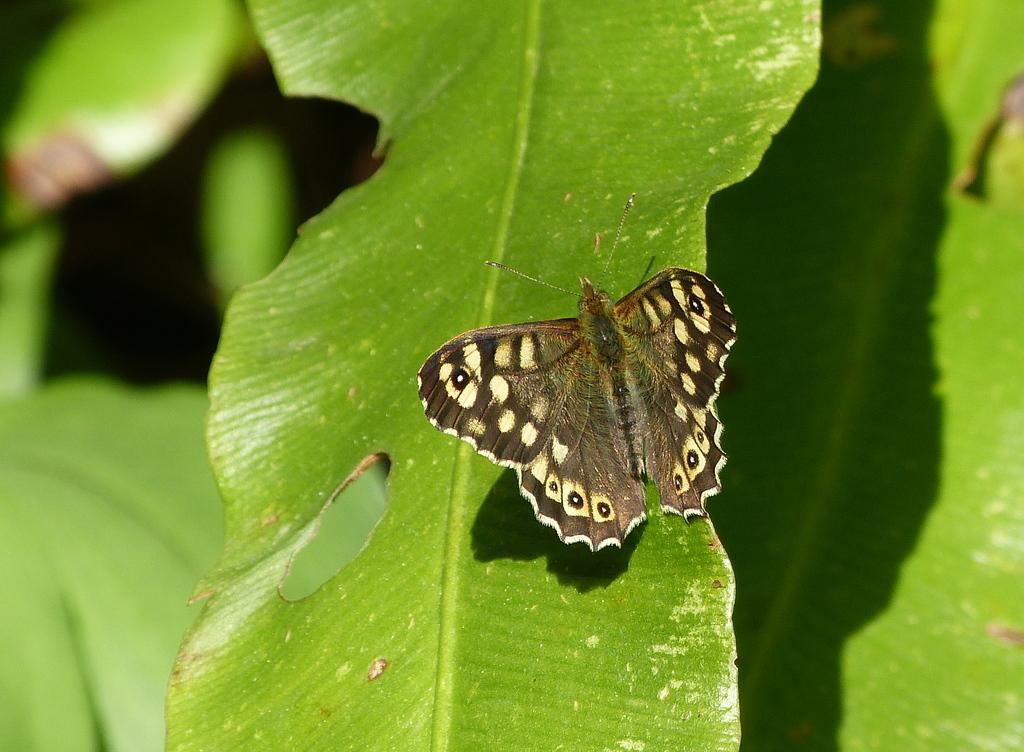What is the main subject of the image? There is a butterfly in the image. Where is the butterfly located? The butterfly is on a leaf. What else can be seen around the butterfly? There are leaves surrounding the butterfly. What type of powder is visible on the floor in the image? There is no floor or powder present in the image; it features a butterfly on a leaf surrounded by leaves. 